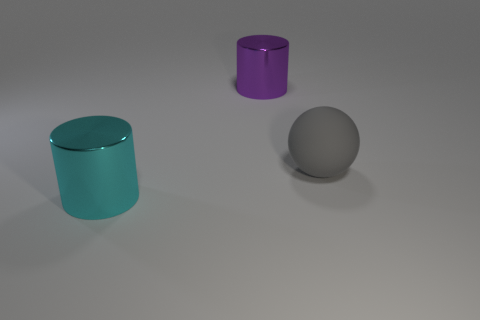Is there anything else that has the same material as the gray sphere?
Give a very brief answer. No. Is the shape of the rubber thing the same as the large metal thing that is to the right of the cyan object?
Offer a terse response. No. How big is the purple metallic object?
Give a very brief answer. Large. Is the number of things behind the big purple cylinder less than the number of large purple metal things?
Provide a succinct answer. Yes. How many cyan metal things are the same size as the gray rubber thing?
Provide a succinct answer. 1. There is a shiny thing that is behind the rubber ball; does it have the same color as the metallic object in front of the big rubber ball?
Your answer should be compact. No. How many large balls are to the right of the large rubber sphere?
Make the answer very short. 0. Are there any other big metal objects of the same shape as the large cyan thing?
Ensure brevity in your answer.  Yes. There is a sphere that is the same size as the cyan shiny thing; what is its color?
Make the answer very short. Gray. Is the number of cyan things left of the large cyan shiny cylinder less than the number of gray objects in front of the purple cylinder?
Offer a terse response. Yes. 